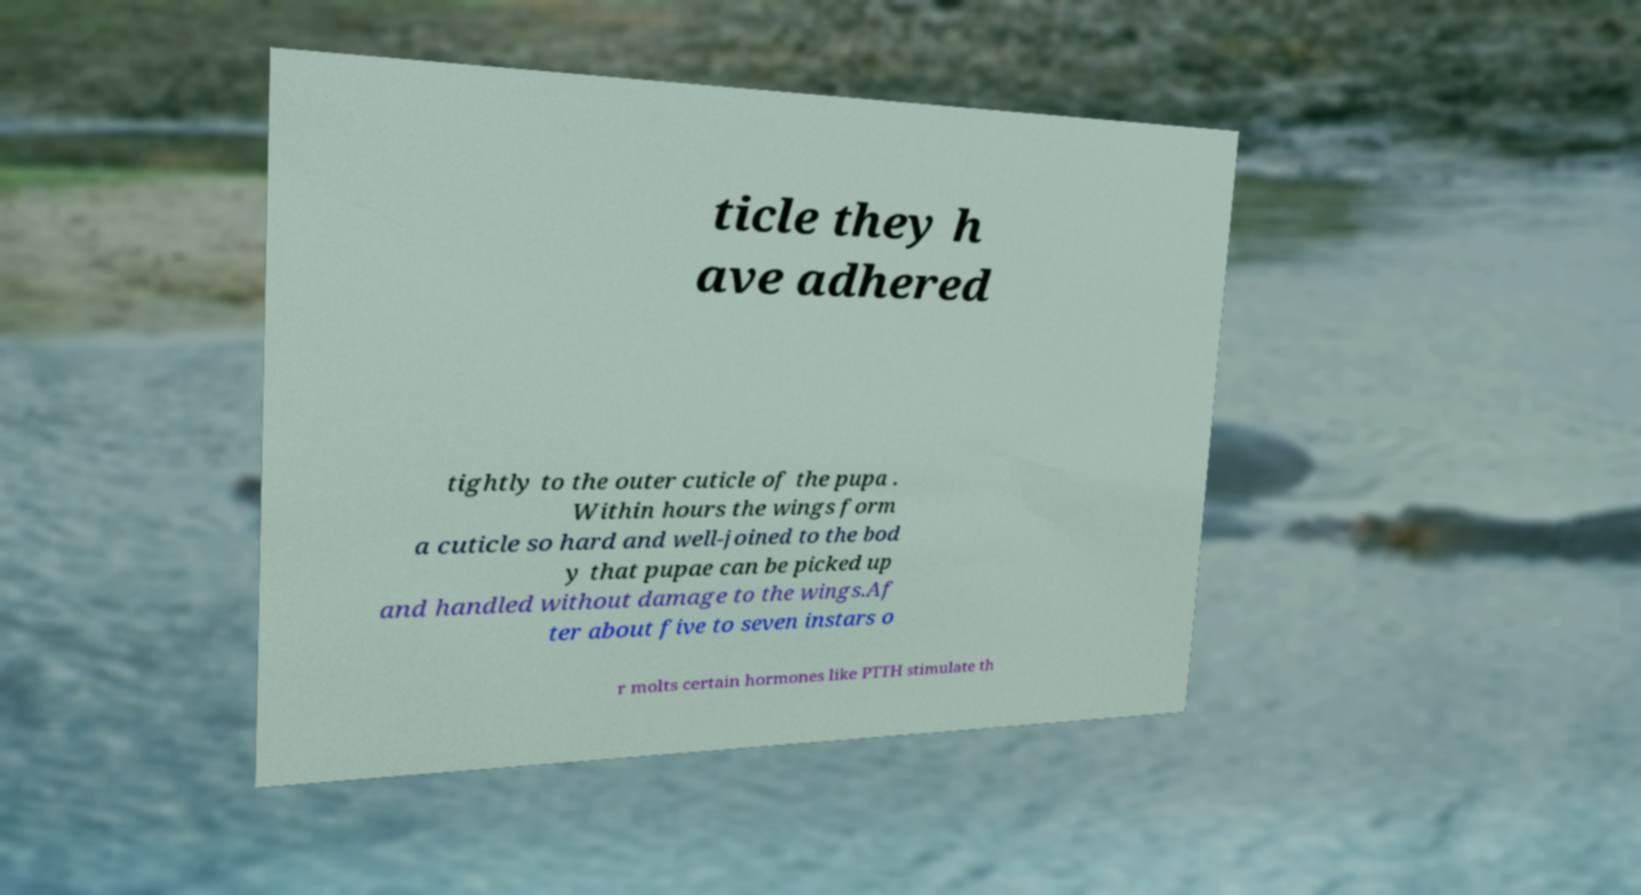There's text embedded in this image that I need extracted. Can you transcribe it verbatim? ticle they h ave adhered tightly to the outer cuticle of the pupa . Within hours the wings form a cuticle so hard and well-joined to the bod y that pupae can be picked up and handled without damage to the wings.Af ter about five to seven instars o r molts certain hormones like PTTH stimulate th 